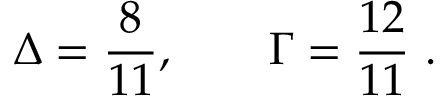Convert formula to latex. <formula><loc_0><loc_0><loc_500><loc_500>\Delta = \frac { 8 } { 1 1 } , \quad \Gamma = \frac { 1 2 } { 1 1 } \ .</formula> 